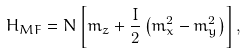Convert formula to latex. <formula><loc_0><loc_0><loc_500><loc_500>H _ { M F } = N \left [ m _ { z } + \frac { I } { 2 } \left ( m _ { x } ^ { 2 } - m _ { y } ^ { 2 } \right ) \right ] ,</formula> 